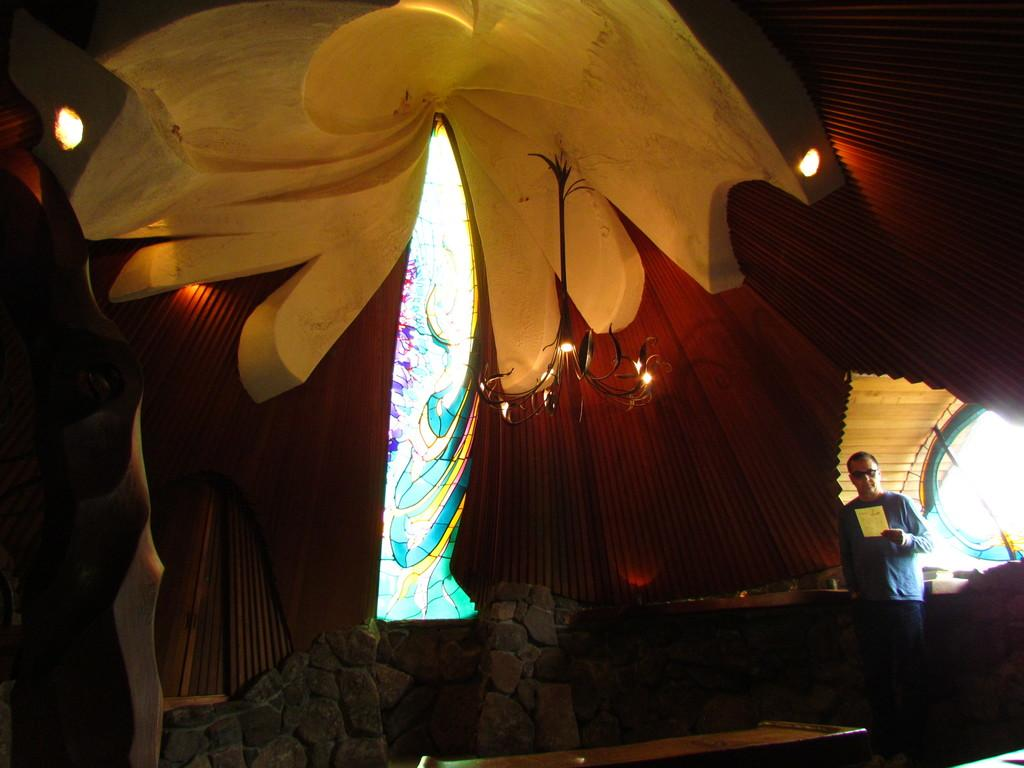What is the person in the image doing? The person is standing on the floor and holding a paper. What objects can be seen on the floor in the image? There are stones visible on the floor in the image. What type of furniture is present in the image? There is a table in the image. What architectural features are visible in the image? There is a wall and windows in the image. What type of lighting is present in the image? There is a chandelier and a roof with lights in the image. How many pigs are visible in the image? There are no pigs present in the image. What force is being applied to the person in the image? There is no force being applied to the person in the image; they are standing on their own. 